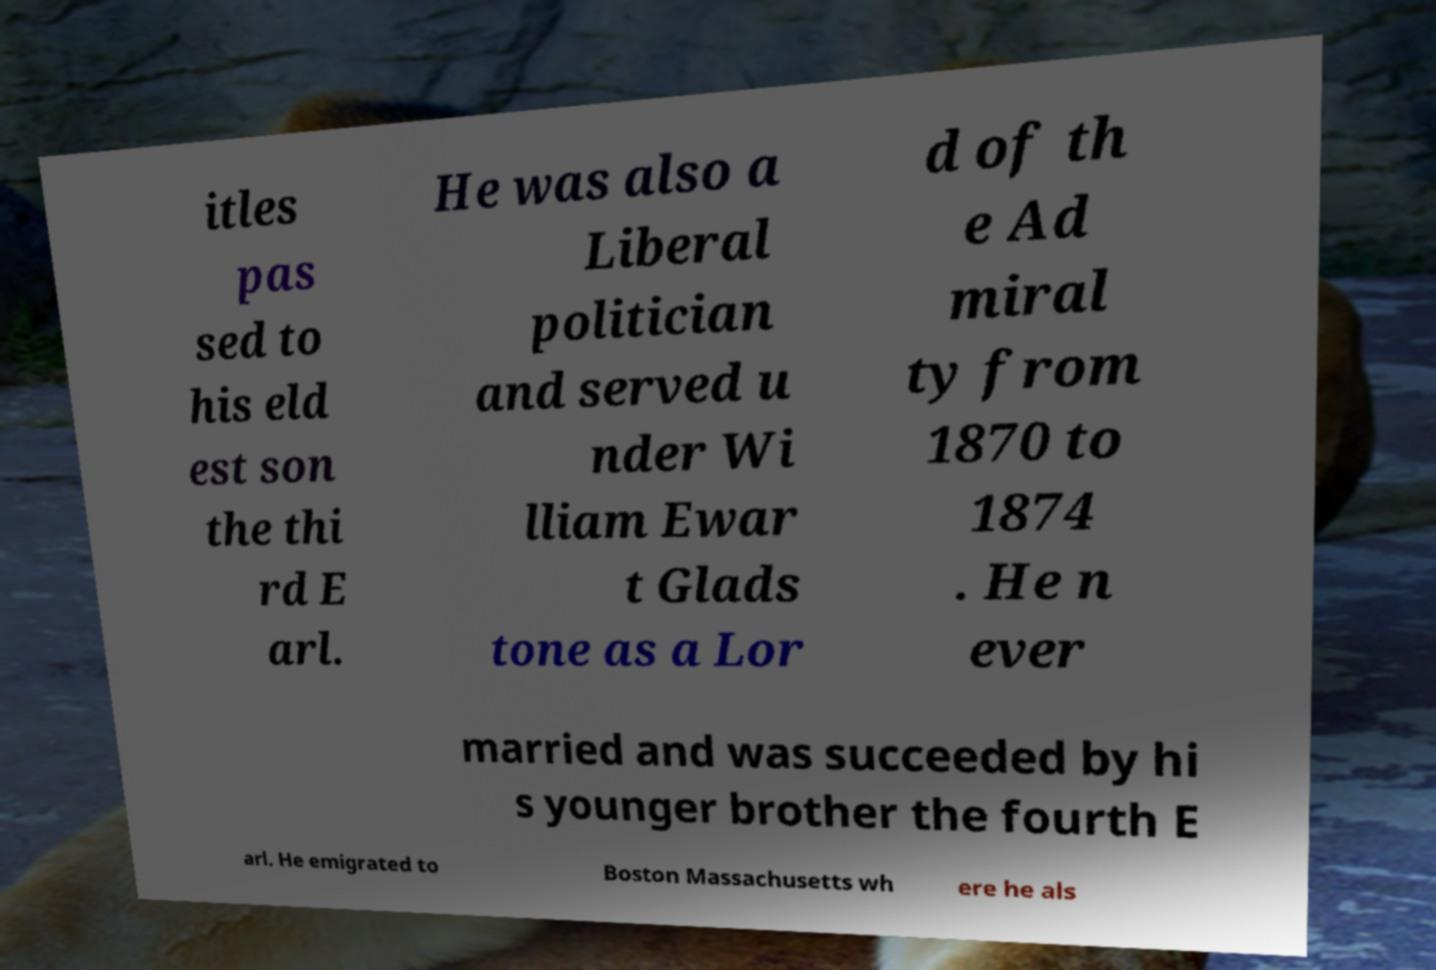Please read and relay the text visible in this image. What does it say? itles pas sed to his eld est son the thi rd E arl. He was also a Liberal politician and served u nder Wi lliam Ewar t Glads tone as a Lor d of th e Ad miral ty from 1870 to 1874 . He n ever married and was succeeded by hi s younger brother the fourth E arl. He emigrated to Boston Massachusetts wh ere he als 